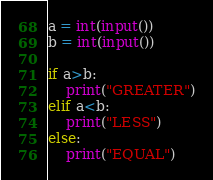<code> <loc_0><loc_0><loc_500><loc_500><_Python_>a = int(input())
b = int(input())

if a>b:
    print("GREATER")
elif a<b:
    print("LESS")
else:
    print("EQUAL")</code> 